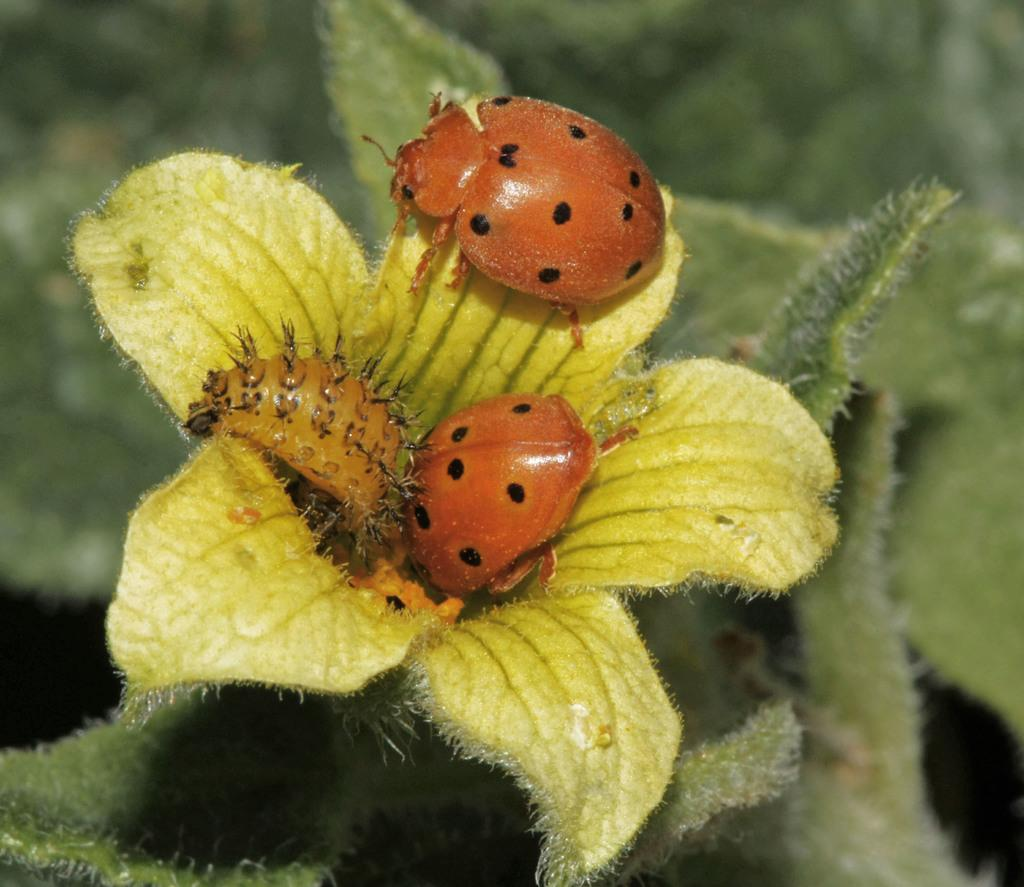What is the main subject of the image? The main subject of the image is insects on a flower. What else can be seen in the image besides the insects and flower? Leaves are visible in the image. What type of volleyball is being offered on the ice in the image? There is no mention of a volleyball or ice in the image; it only describes insects on a flower and leaves. 